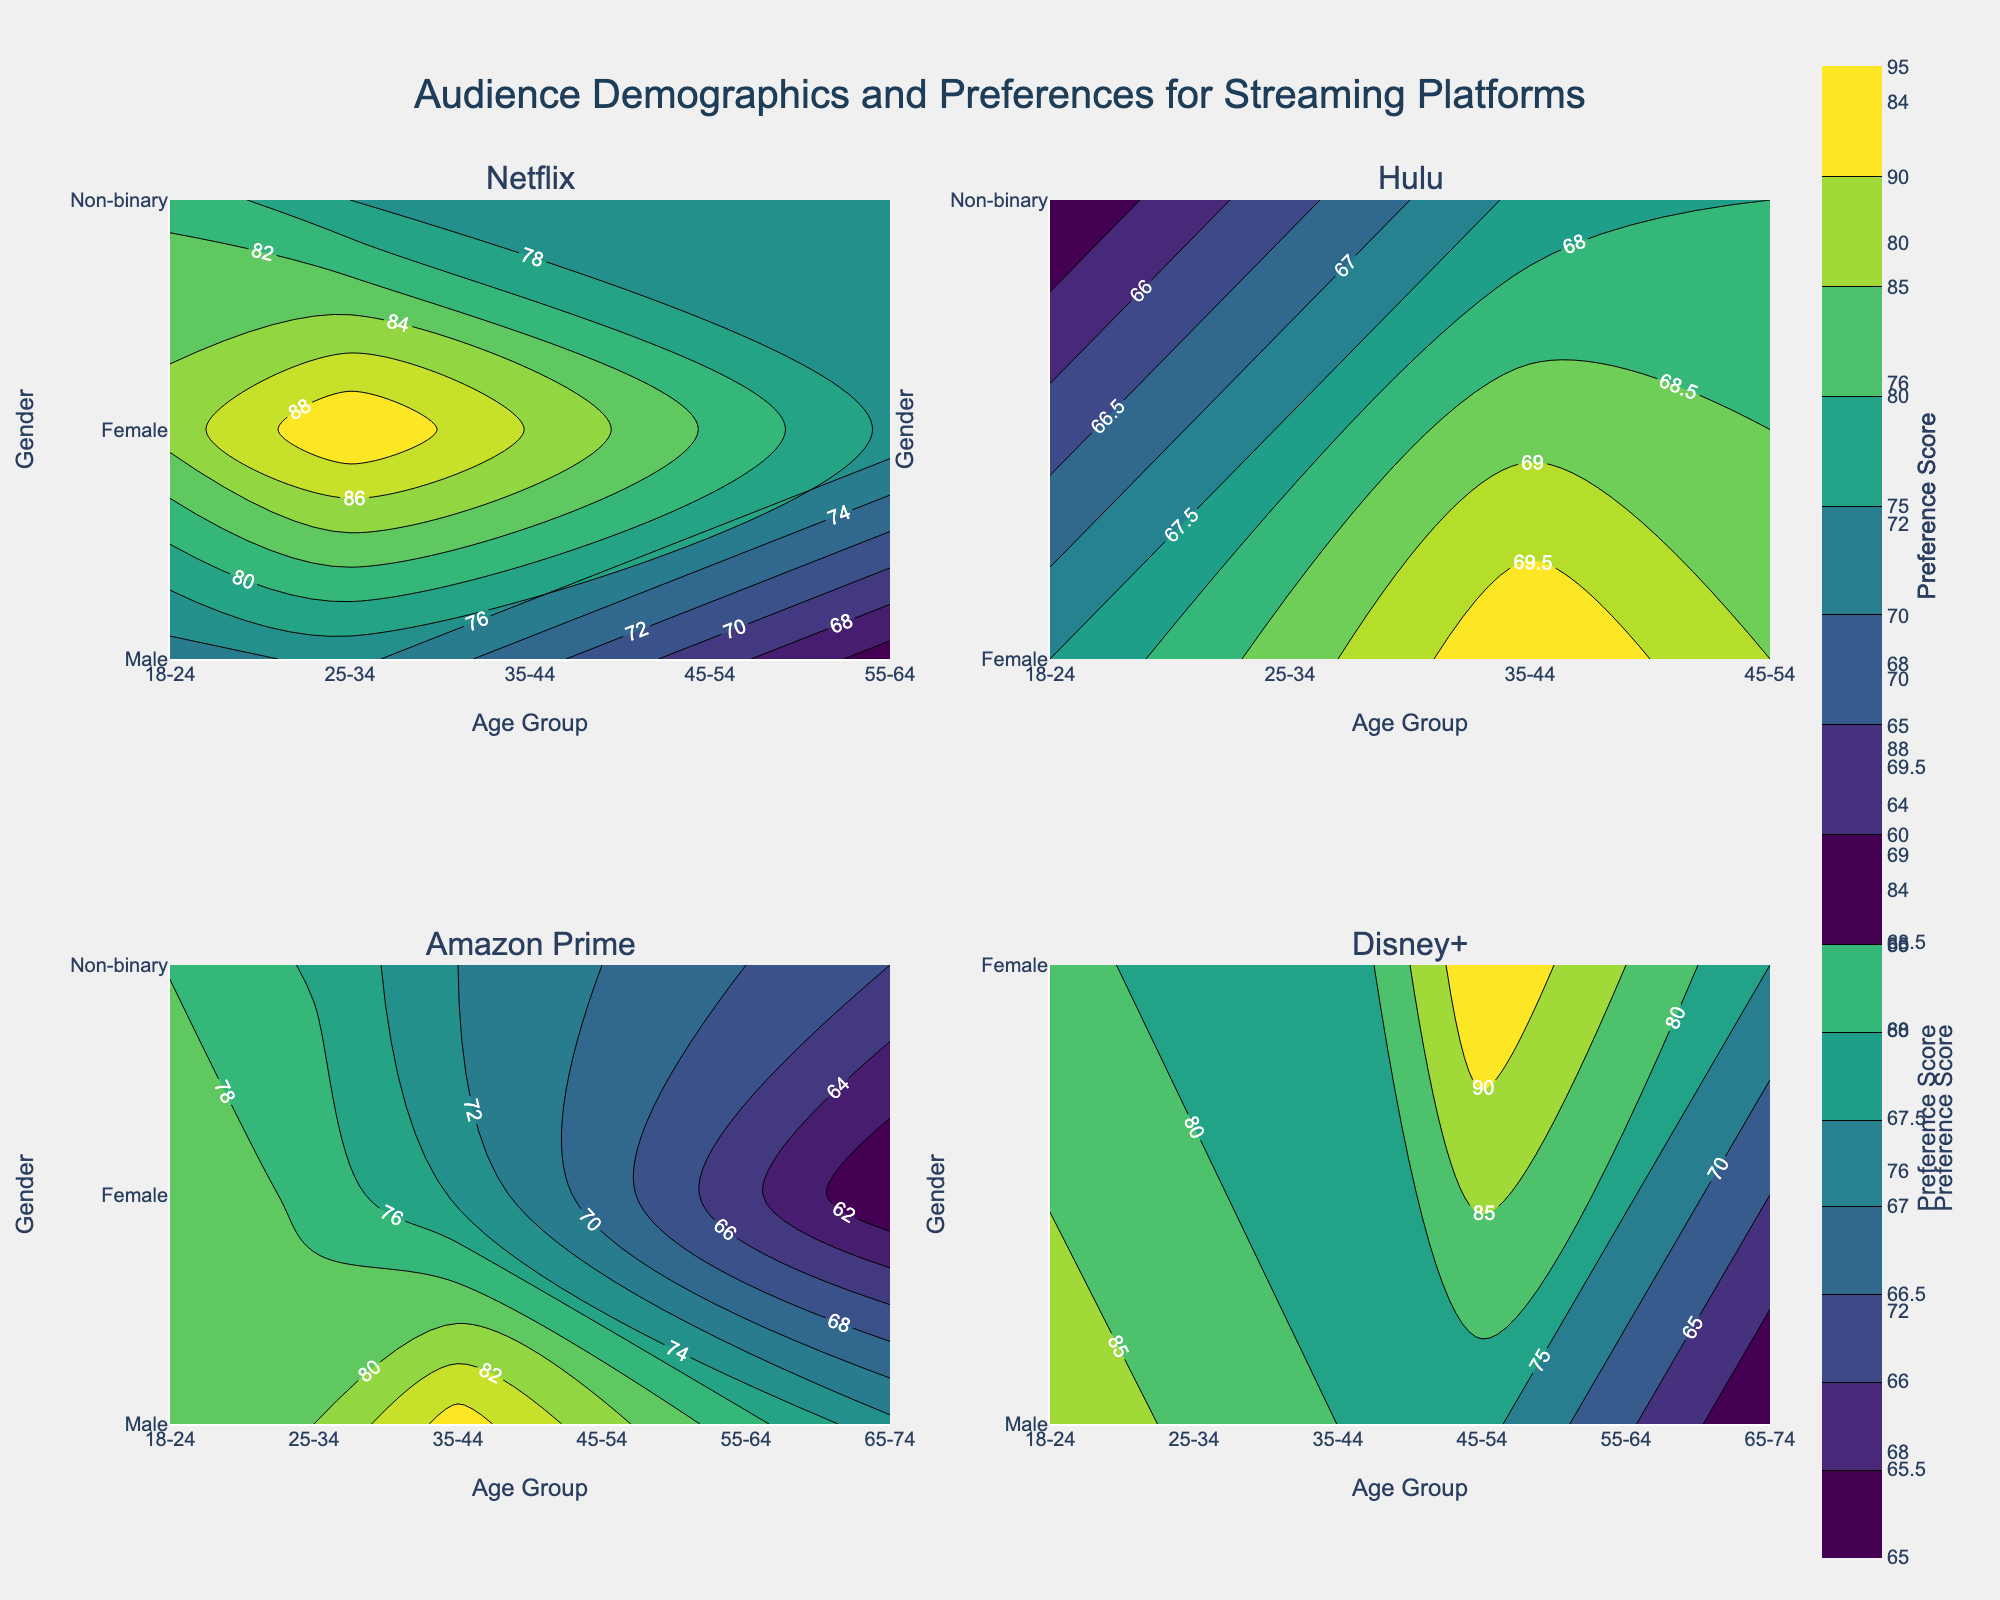What is the title of the figure? The title of a figure is usually displayed prominently at the top, summarizing the overall content of the plot. In this case, the instructions specified the title to be set as "Audience Demographics and Preferences for Streaming Platforms".
Answer: Audience Demographics and Preferences for Streaming Platforms Which age group shows the highest preference score for Netflix? Looking at the subplot for Netflix, locate the contour levels corresponding to age groups. The highest preference score would be in the region with the darkest color (as 'Viridis' colorscale ranks preference from light to dark).
Answer: 25-34 (Female) How many subplots are present in the figure and what are their titles? The figure is specified to have 4 subplots, which can be gathered from the subplot titles. In the instructions, platforms used were limited to the first four streaming services. The titles would correspond to these first four platforms.
Answer: 4; Netflix, Hulu, Amazon Prime, Disney+ Which gender and age group combination has the highest preference score for Disney+? For Disney+, identify the darkest region on the contour plot. Then, cross-reference with the age and gender axes to pinpoint the exact combination.
Answer: 45-54 (Female) What streaming platform has the lowest gender variation for age group 18-24? Check all four subplots for the 18-24 age group. The gender variation (diversity in gender preference) can be inferred by how uniformly the preference scores are distributed across genders for this age group. The platform with the least variation will have more uniform color distribution horizontally at the specific age group.
Answer: Hulu Which age and gender combination has the least preference score for Amazon Prime? For Amazon Prime, locate the lightest color contour level in its subplot. Then, map it back to the coordinates corresponding to age and gender axes.
Answer: 65-74 (Female) In Netflix, what gender has the highest average preference score across all age groups? For Netflix, visualize all age groups and compare the darkness of colors horizontally across gender. The one with the overall darkest (higher) averaged across all age groups will represent the gender with the highest average score.
Answer: Female Compare the preference scores for age group 35-44 between Netflix and Hulu. Which one scores higher on average and for which gender? Look at the contour marks corresponding to age group 35-44 from both Netflix and Hulu subplots, then compare the contour levels for the Male, Female, and Non-binary genders to determine which streaming service has a higher average score overall for this group.
Answer: Netflix (Female) What are the ranges of the preference scores depicted in the contour plots? All contour plots share a common colorbar showing the range of preference scores, which can be located beside any of the subplots. The starting and ending values on this bar give the full range of the scores.
Answer: 55 to 95 